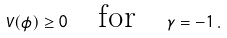<formula> <loc_0><loc_0><loc_500><loc_500>V ( \phi ) \geq 0 \quad \text {for} \quad \gamma = - 1 \, .</formula> 